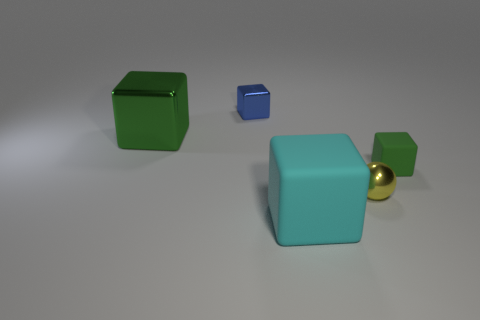Subtract all small blue blocks. How many blocks are left? 3 Subtract 1 cubes. How many cubes are left? 3 Add 1 small rubber things. How many objects exist? 6 Subtract all gray cubes. Subtract all yellow cylinders. How many cubes are left? 4 Subtract all cubes. How many objects are left? 1 Subtract all small brown shiny cubes. Subtract all matte blocks. How many objects are left? 3 Add 4 cubes. How many cubes are left? 8 Add 2 blue metallic blocks. How many blue metallic blocks exist? 3 Subtract 0 blue cylinders. How many objects are left? 5 